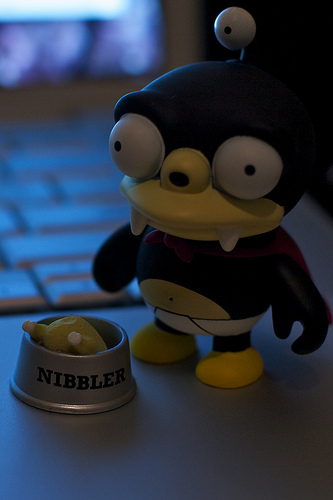<image>
Is the doll above the floor? No. The doll is not positioned above the floor. The vertical arrangement shows a different relationship. 